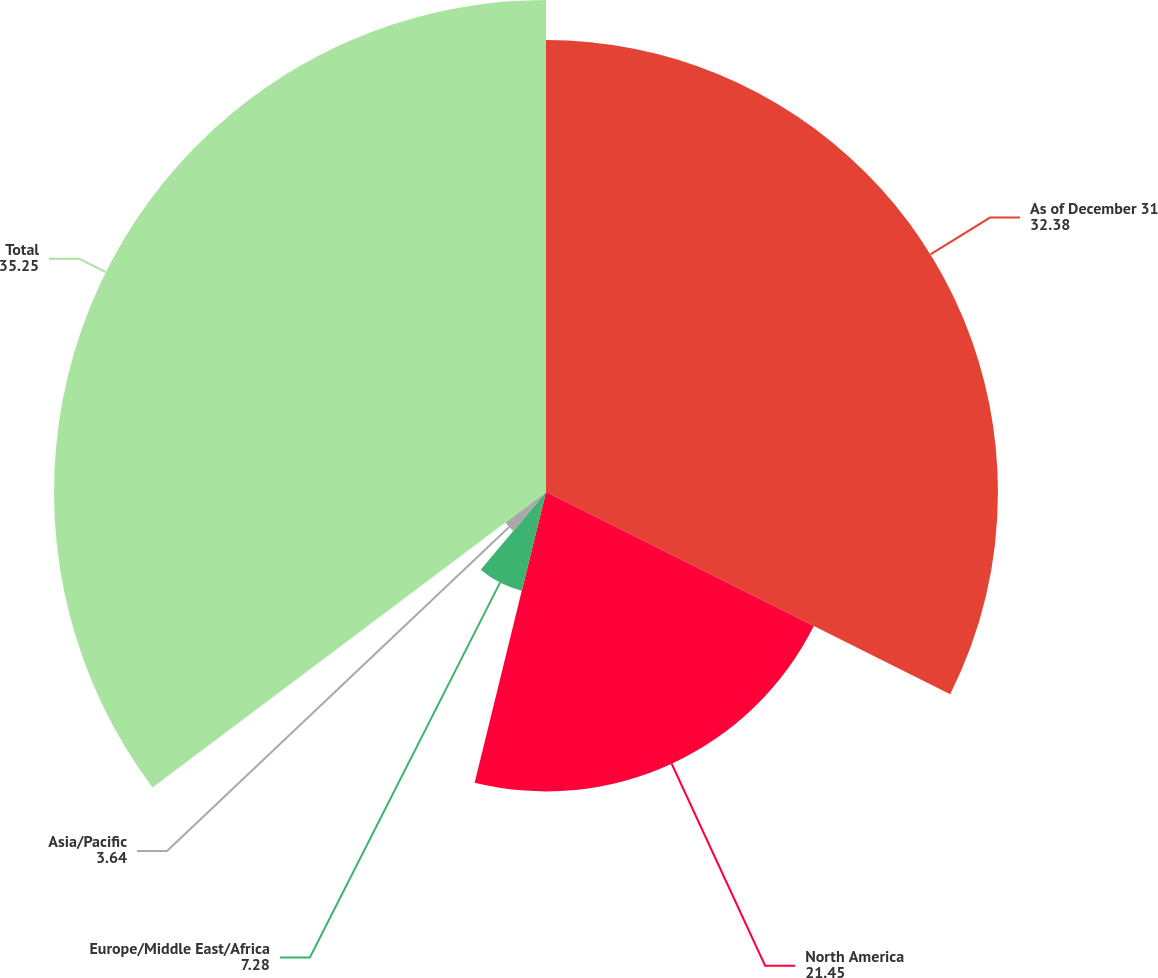Convert chart to OTSL. <chart><loc_0><loc_0><loc_500><loc_500><pie_chart><fcel>As of December 31<fcel>North America<fcel>Europe/Middle East/Africa<fcel>Asia/Pacific<fcel>Total<nl><fcel>32.38%<fcel>21.45%<fcel>7.28%<fcel>3.64%<fcel>35.25%<nl></chart> 